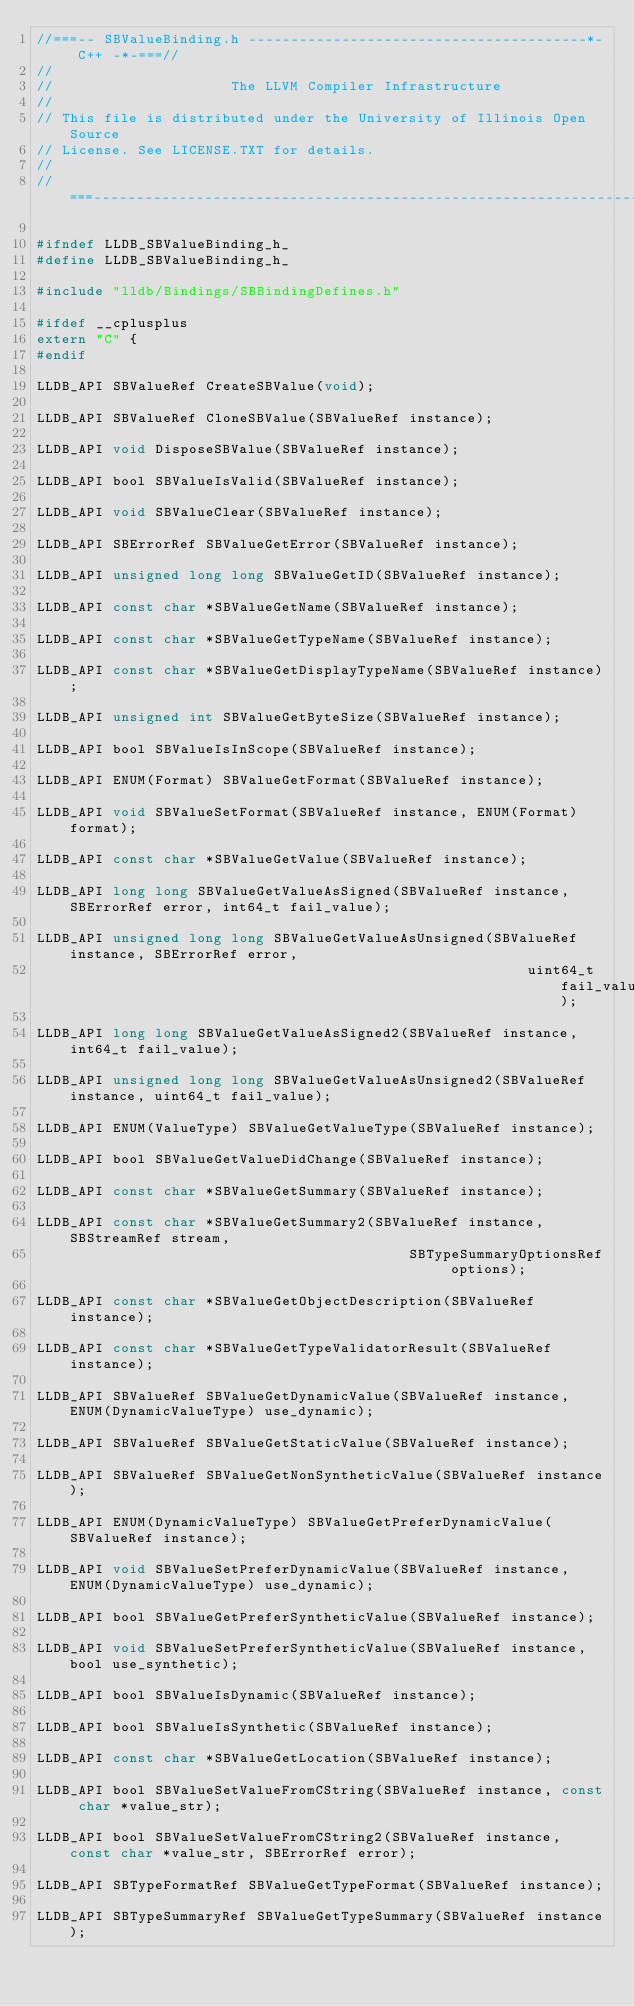<code> <loc_0><loc_0><loc_500><loc_500><_C_>//===-- SBValueBinding.h ----------------------------------------*- C++ -*-===//
//
//                     The LLVM Compiler Infrastructure
//
// This file is distributed under the University of Illinois Open Source
// License. See LICENSE.TXT for details.
//
//===----------------------------------------------------------------------===//

#ifndef LLDB_SBValueBinding_h_
#define LLDB_SBValueBinding_h_

#include "lldb/Bindings/SBBindingDefines.h"

#ifdef __cplusplus
extern "C" {
#endif

LLDB_API SBValueRef CreateSBValue(void);

LLDB_API SBValueRef CloneSBValue(SBValueRef instance);

LLDB_API void DisposeSBValue(SBValueRef instance);

LLDB_API bool SBValueIsValid(SBValueRef instance);

LLDB_API void SBValueClear(SBValueRef instance);

LLDB_API SBErrorRef SBValueGetError(SBValueRef instance);

LLDB_API unsigned long long SBValueGetID(SBValueRef instance);

LLDB_API const char *SBValueGetName(SBValueRef instance);

LLDB_API const char *SBValueGetTypeName(SBValueRef instance);

LLDB_API const char *SBValueGetDisplayTypeName(SBValueRef instance);

LLDB_API unsigned int SBValueGetByteSize(SBValueRef instance);

LLDB_API bool SBValueIsInScope(SBValueRef instance);

LLDB_API ENUM(Format) SBValueGetFormat(SBValueRef instance);

LLDB_API void SBValueSetFormat(SBValueRef instance, ENUM(Format) format);

LLDB_API const char *SBValueGetValue(SBValueRef instance);

LLDB_API long long SBValueGetValueAsSigned(SBValueRef instance, SBErrorRef error, int64_t fail_value);

LLDB_API unsigned long long SBValueGetValueAsUnsigned(SBValueRef instance, SBErrorRef error,
                                                          uint64_t fail_value);

LLDB_API long long SBValueGetValueAsSigned2(SBValueRef instance, int64_t fail_value);

LLDB_API unsigned long long SBValueGetValueAsUnsigned2(SBValueRef instance, uint64_t fail_value);

LLDB_API ENUM(ValueType) SBValueGetValueType(SBValueRef instance);

LLDB_API bool SBValueGetValueDidChange(SBValueRef instance);

LLDB_API const char *SBValueGetSummary(SBValueRef instance);

LLDB_API const char *SBValueGetSummary2(SBValueRef instance, SBStreamRef stream,
                                            SBTypeSummaryOptionsRef options);

LLDB_API const char *SBValueGetObjectDescription(SBValueRef instance);

LLDB_API const char *SBValueGetTypeValidatorResult(SBValueRef instance);

LLDB_API SBValueRef SBValueGetDynamicValue(SBValueRef instance, ENUM(DynamicValueType) use_dynamic);

LLDB_API SBValueRef SBValueGetStaticValue(SBValueRef instance);

LLDB_API SBValueRef SBValueGetNonSyntheticValue(SBValueRef instance);

LLDB_API ENUM(DynamicValueType) SBValueGetPreferDynamicValue(SBValueRef instance);

LLDB_API void SBValueSetPreferDynamicValue(SBValueRef instance, ENUM(DynamicValueType) use_dynamic);

LLDB_API bool SBValueGetPreferSyntheticValue(SBValueRef instance);

LLDB_API void SBValueSetPreferSyntheticValue(SBValueRef instance, bool use_synthetic);

LLDB_API bool SBValueIsDynamic(SBValueRef instance);

LLDB_API bool SBValueIsSynthetic(SBValueRef instance);

LLDB_API const char *SBValueGetLocation(SBValueRef instance);

LLDB_API bool SBValueSetValueFromCString(SBValueRef instance, const char *value_str);

LLDB_API bool SBValueSetValueFromCString2(SBValueRef instance, const char *value_str, SBErrorRef error);

LLDB_API SBTypeFormatRef SBValueGetTypeFormat(SBValueRef instance);

LLDB_API SBTypeSummaryRef SBValueGetTypeSummary(SBValueRef instance);
</code> 